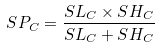Convert formula to latex. <formula><loc_0><loc_0><loc_500><loc_500>S P _ { C } = \frac { S L _ { C } \times S H _ { C } } { S L _ { C } + S H _ { C } }</formula> 